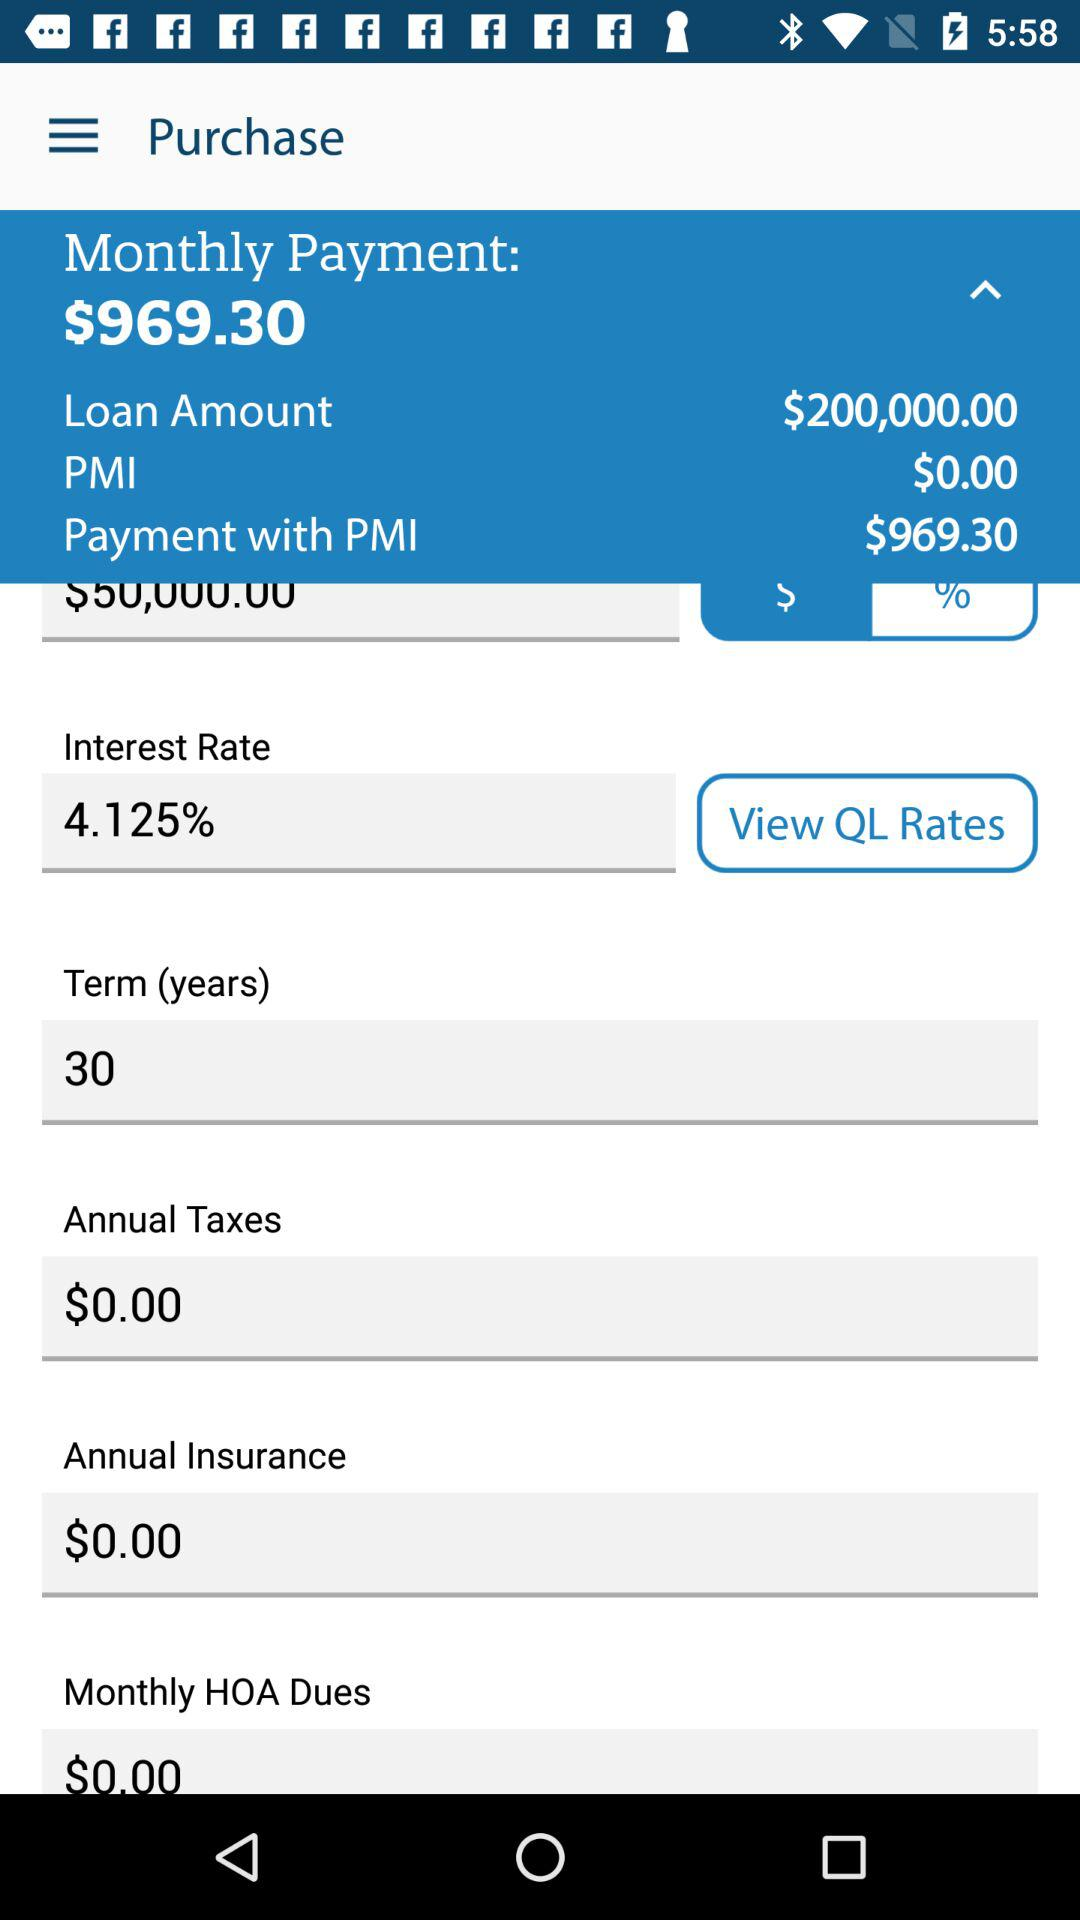How much is the monthly payment? The monthly payment is $969.30. 